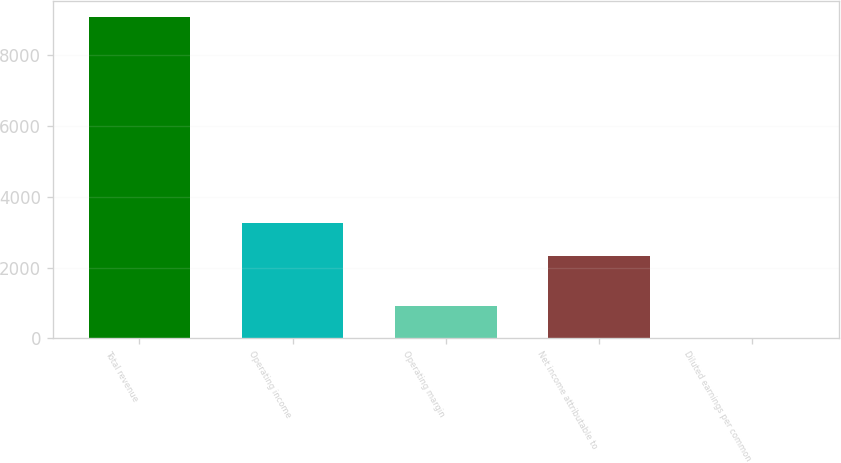<chart> <loc_0><loc_0><loc_500><loc_500><bar_chart><fcel>Total revenue<fcel>Operating income<fcel>Operating margin<fcel>Net income attributable to<fcel>Diluted earnings per common<nl><fcel>9081<fcel>3249<fcel>919.23<fcel>2337<fcel>12.37<nl></chart> 